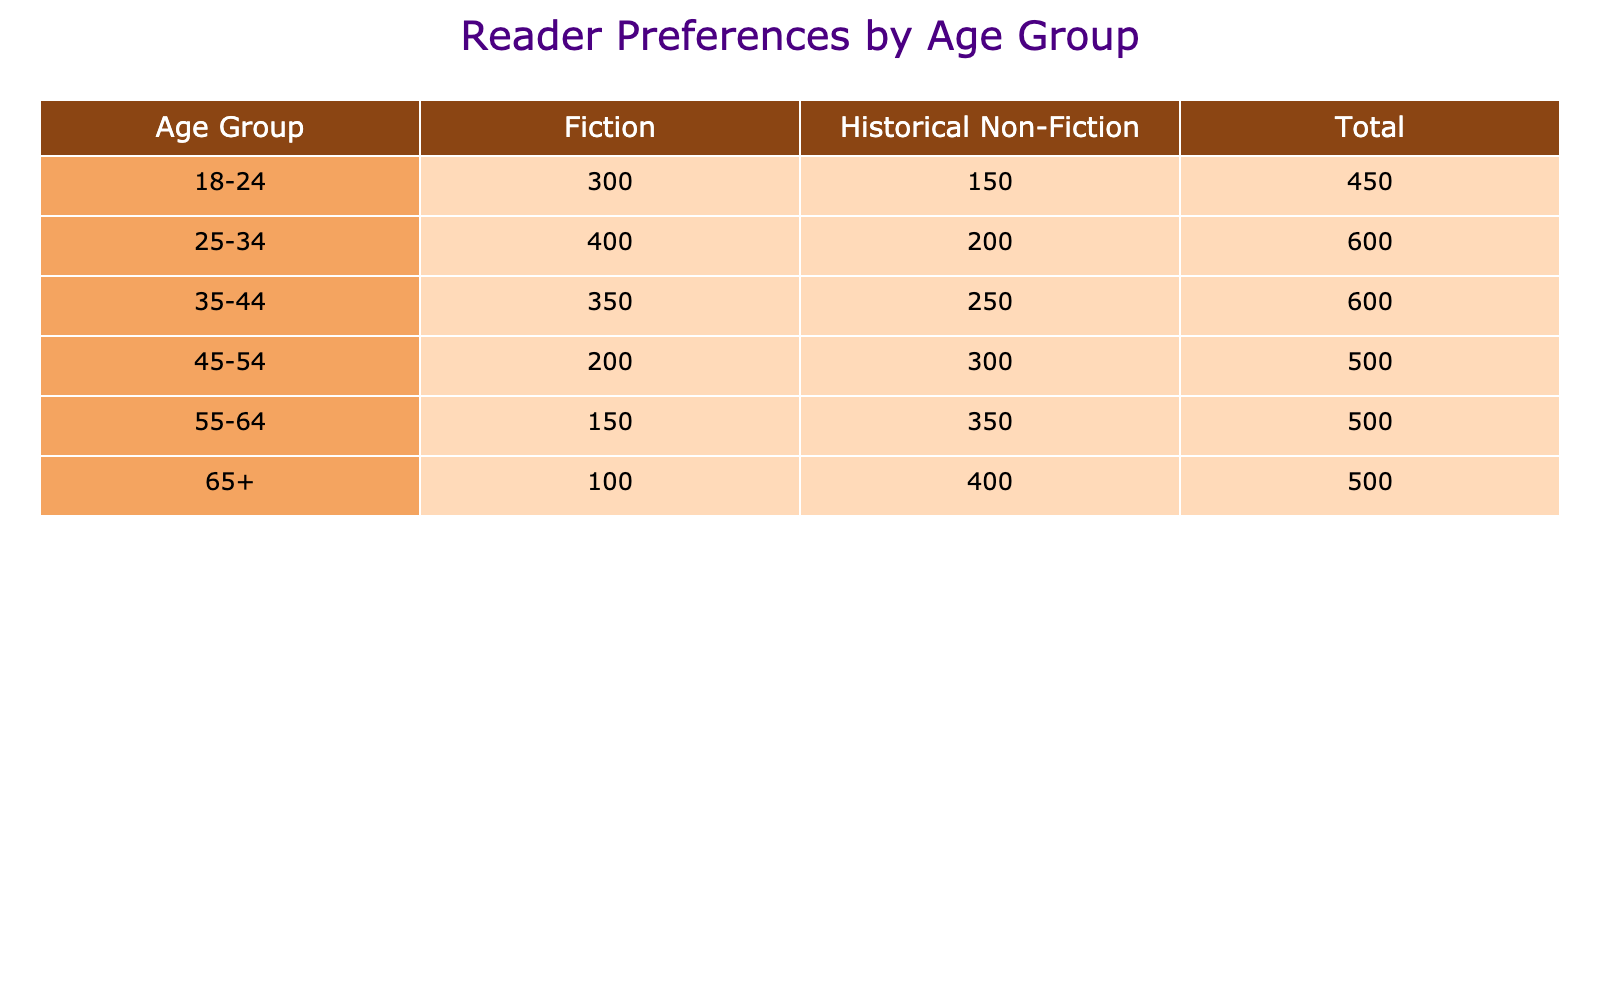What age group has the highest preference for Historical Non-Fiction? Looking at the "Historical Non-Fiction" column, the age group with the highest count is 65+, with a total of 400 readers preferring this genre.
Answer: 65+ What is the total number of readers who prefer Fiction across all age groups? To find the total for Fiction, sum the counts in the Fiction column: 300 + 400 + 350 + 200 + 150 + 100 = 1500.
Answer: 1500 Which age group has a more balanced preference between Fiction and Historical Non-Fiction? The age group 35-44 has counts of 350 for Fiction and 250 for Historical Non-Fiction. The difference (350 - 250) is 100, which is the smallest difference among all age groups, indicating a more balanced preference.
Answer: 35-44 Is the total number of readers who prefer Historical Non-Fiction greater than those who prefer Fiction? To determine this, compare the totals for both: Fiction total is 1500 and Historical Non-Fiction total is 1850 (150 + 200 + 250 + 300 + 350 + 400 = 1850). Since 1850 is greater than 1500, the statement is true.
Answer: Yes What is the difference in preference for Fiction and Historical Non-Fiction between the 45-54 age group? In the 45-54 age group, 200 prefer Fiction while 300 prefer Historical Non-Fiction. The difference is 300 - 200 = 100 in favor of Historical Non-Fiction.
Answer: 100 